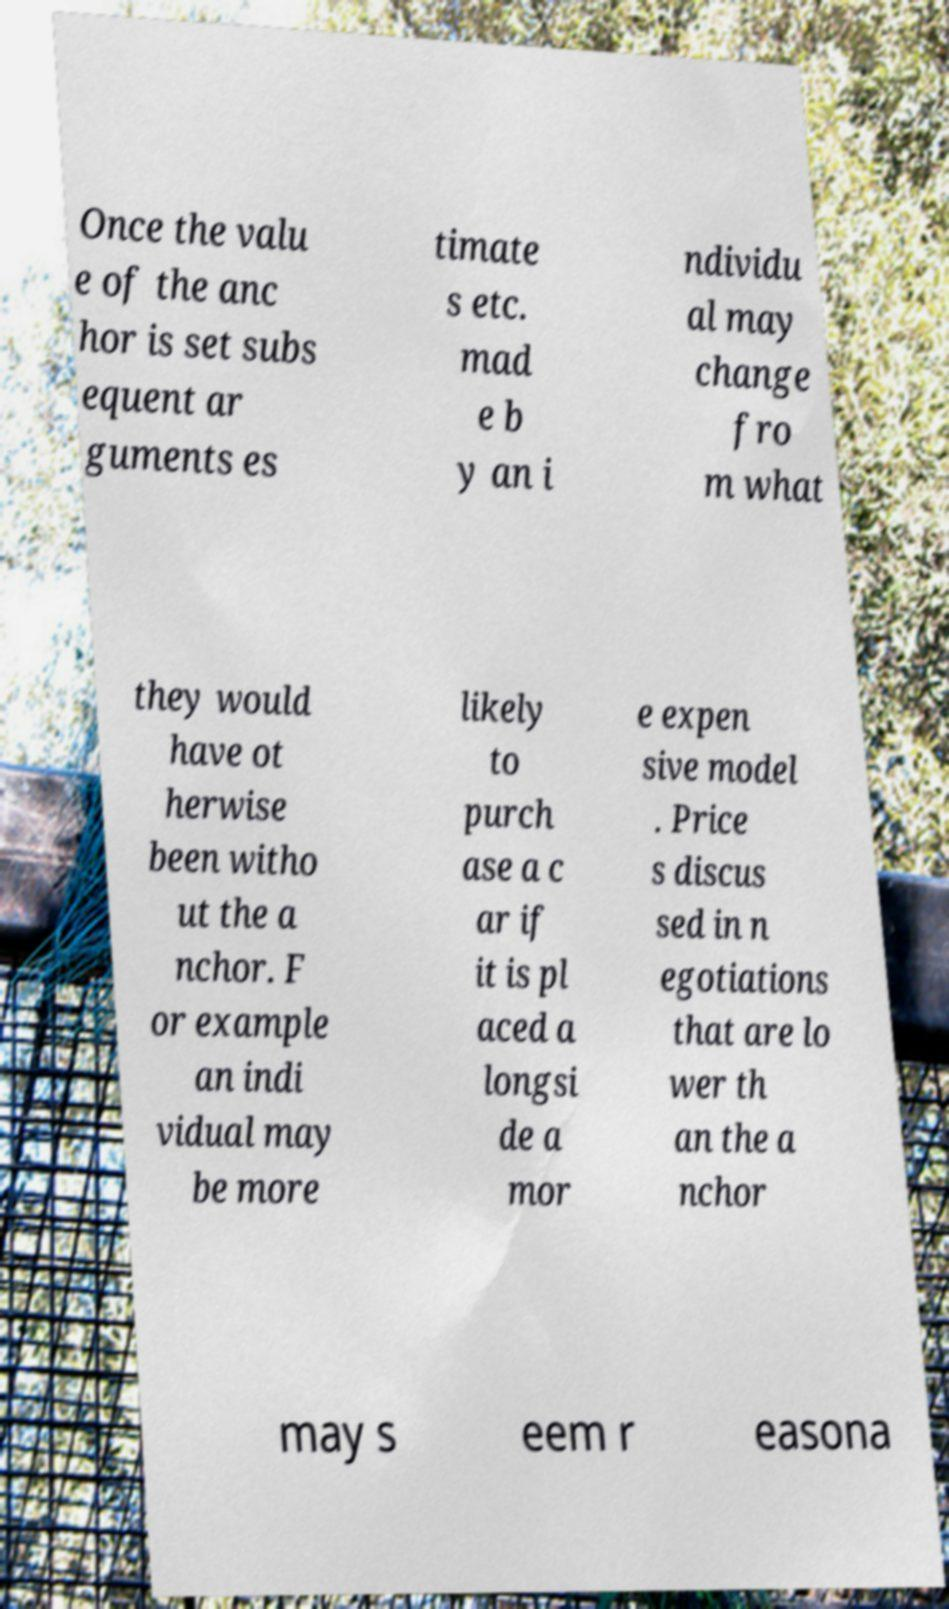Could you assist in decoding the text presented in this image and type it out clearly? Once the valu e of the anc hor is set subs equent ar guments es timate s etc. mad e b y an i ndividu al may change fro m what they would have ot herwise been witho ut the a nchor. F or example an indi vidual may be more likely to purch ase a c ar if it is pl aced a longsi de a mor e expen sive model . Price s discus sed in n egotiations that are lo wer th an the a nchor may s eem r easona 